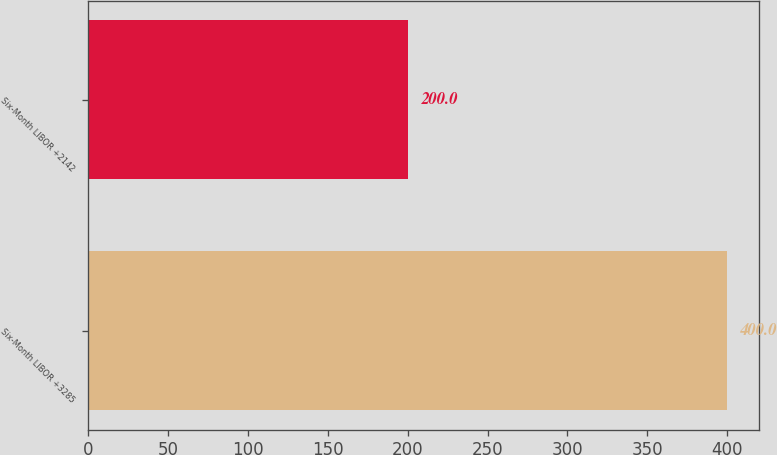Convert chart to OTSL. <chart><loc_0><loc_0><loc_500><loc_500><bar_chart><fcel>Six-Month LIBOR +3285<fcel>Six-Month LIBOR +2142<nl><fcel>400<fcel>200<nl></chart> 